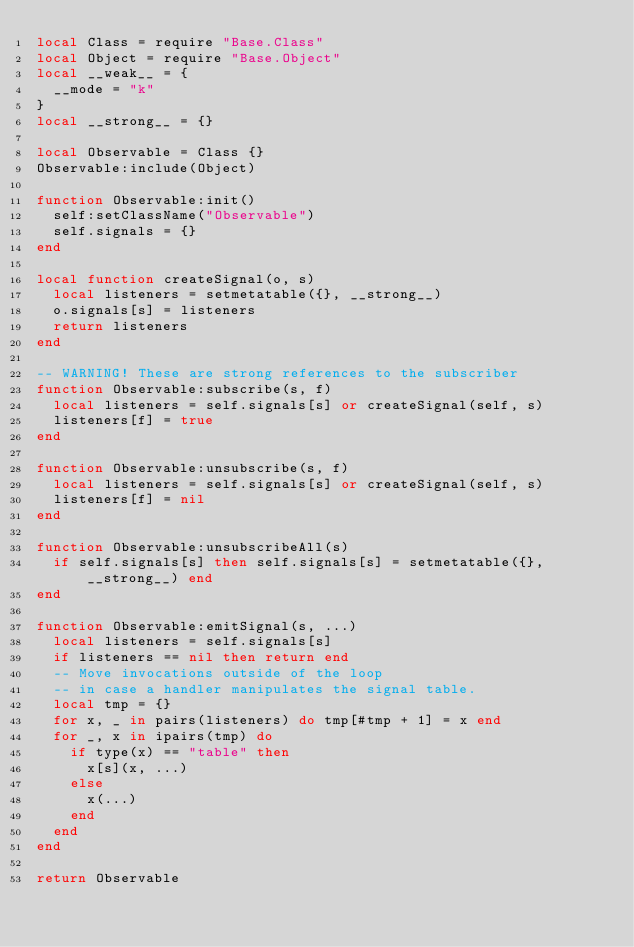Convert code to text. <code><loc_0><loc_0><loc_500><loc_500><_Lua_>local Class = require "Base.Class"
local Object = require "Base.Object"
local __weak__ = {
  __mode = "k"
}
local __strong__ = {}

local Observable = Class {}
Observable:include(Object)

function Observable:init()
  self:setClassName("Observable")
  self.signals = {}
end

local function createSignal(o, s)
  local listeners = setmetatable({}, __strong__)
  o.signals[s] = listeners
  return listeners
end

-- WARNING! These are strong references to the subscriber
function Observable:subscribe(s, f)
  local listeners = self.signals[s] or createSignal(self, s)
  listeners[f] = true
end

function Observable:unsubscribe(s, f)
  local listeners = self.signals[s] or createSignal(self, s)
  listeners[f] = nil
end

function Observable:unsubscribeAll(s)
  if self.signals[s] then self.signals[s] = setmetatable({}, __strong__) end
end

function Observable:emitSignal(s, ...)
  local listeners = self.signals[s]
  if listeners == nil then return end
  -- Move invocations outside of the loop
  -- in case a handler manipulates the signal table.
  local tmp = {}
  for x, _ in pairs(listeners) do tmp[#tmp + 1] = x end
  for _, x in ipairs(tmp) do
    if type(x) == "table" then
      x[s](x, ...)
    else
      x(...)
    end
  end
end

return Observable
</code> 